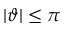<formula> <loc_0><loc_0><loc_500><loc_500>| \vartheta | \leq \pi</formula> 